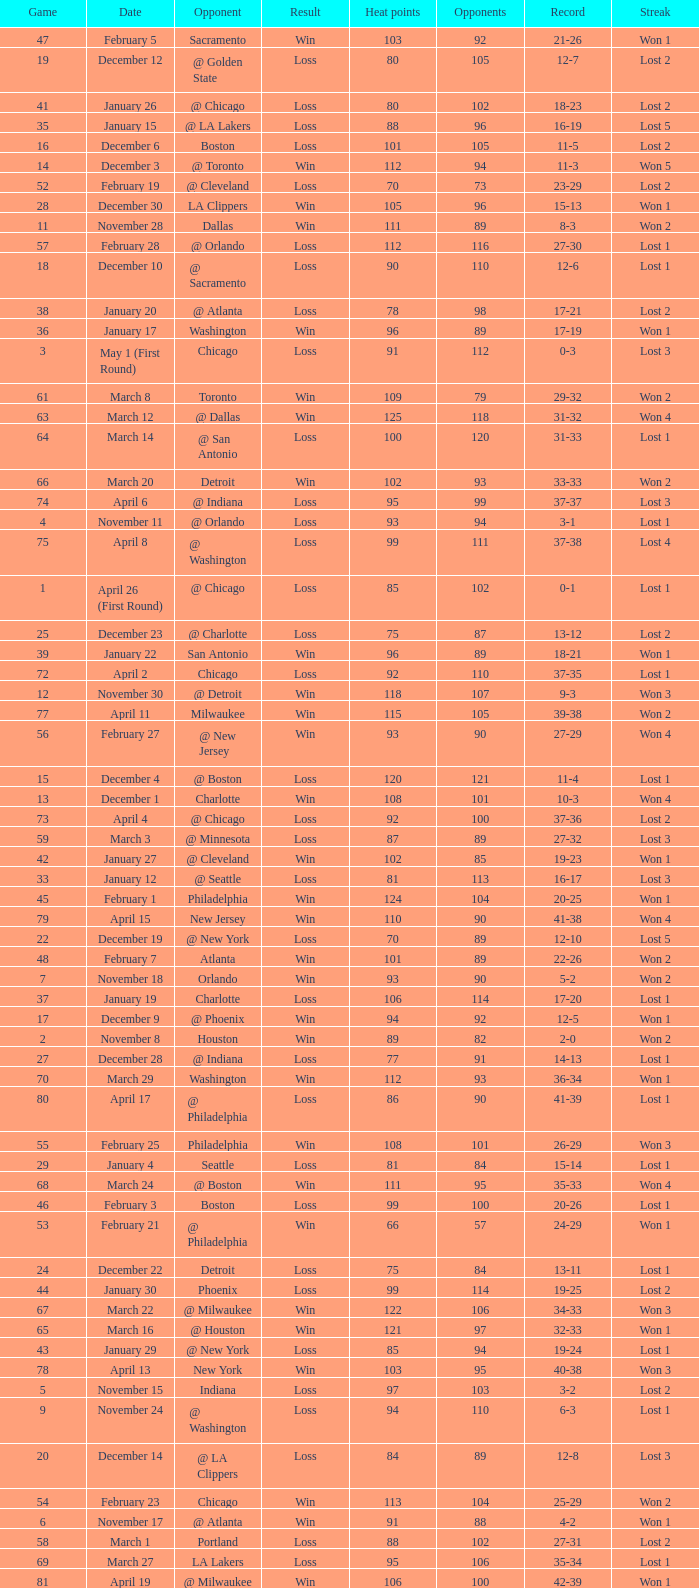What is Streak, when Heat Points is "101", and when Game is "16"? Lost 2. 